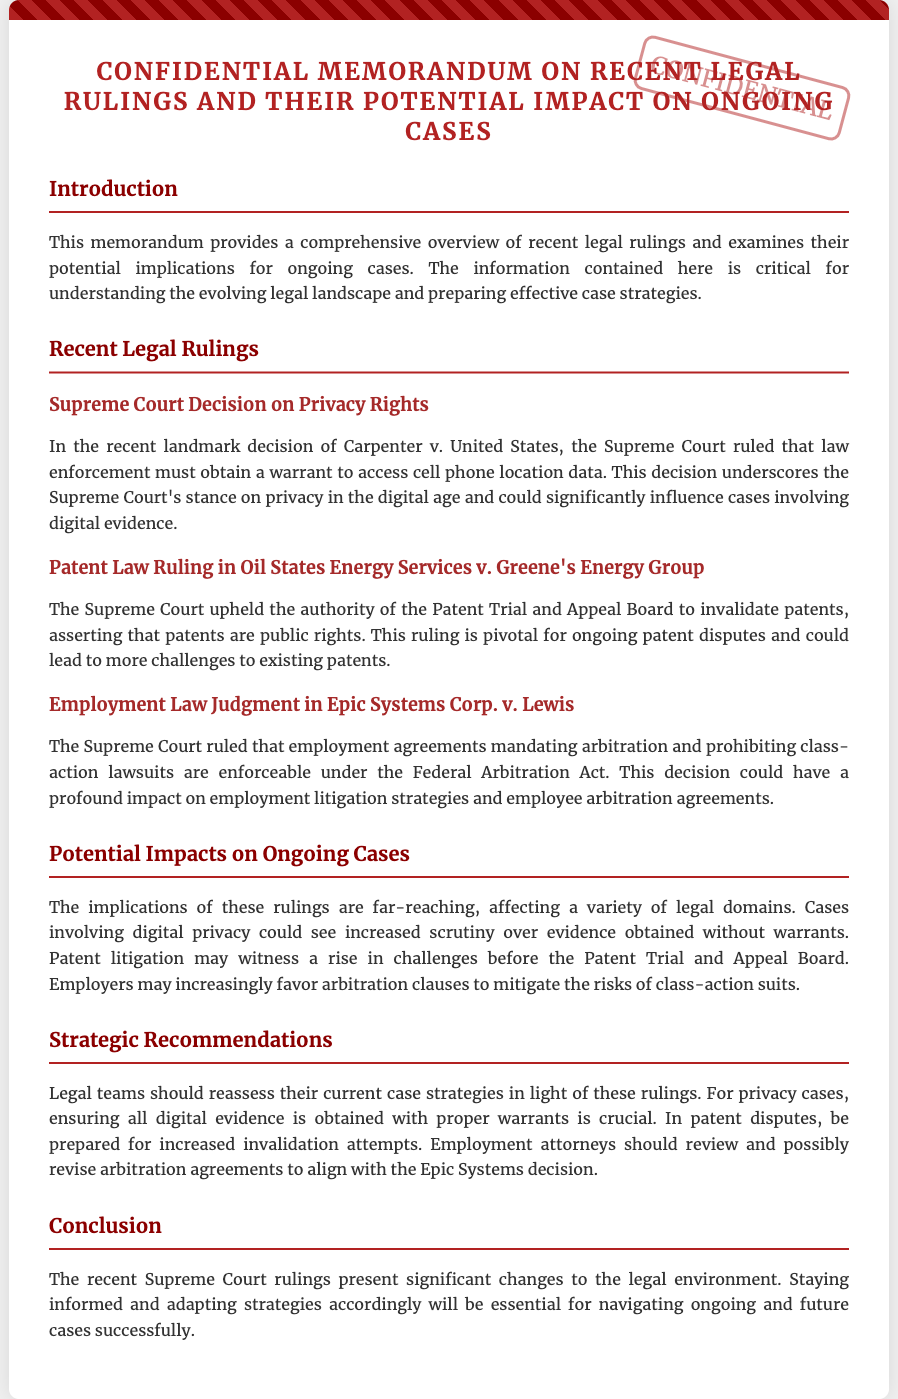What is the title of the memorandum? The title provides the main subject of the document, which is "Confidential Memorandum on Recent Legal Rulings and Their Potential Impact on Ongoing Cases".
Answer: Confidential Memorandum on Recent Legal Rulings and Their Potential Impact on Ongoing Cases What Supreme Court case addressed privacy rights? This refers to a specific legal case discussed in the document, which is "Carpenter v. United States".
Answer: Carpenter v. United States What ruling was made regarding patent law? This refers to the legal ruling mentioned that involves patents, specifically in "Oil States Energy Services v. Greene's Energy Group".
Answer: Oil States Energy Services v. Greene's Energy Group Which act does the Epic Systems Corp. v. Lewis case relate to? This question identifies the legal framework involved in the employment law ruling mentioned in the document.
Answer: Federal Arbitration Act What is one strategic recommendation for legal teams? This refers to advice given in the document that emphasizes the importance of a specific action legal teams should take.
Answer: Reassess current case strategies How many recent legal rulings are discussed? This question seeks to identify the count of major segments covered in the memorandum.
Answer: Three What is the implications of the Carpenter v. United States decision? This assesses the potential influence of a specific ruling on future cases, particularly those involving digital evidence.
Answer: Increased scrutiny over evidence obtained without warrants What color is the confidential stamp? This question focuses on the visual aspects of the document related to the confidentiality notice.
Answer: Red What area of law does Epic Systems Corp. v. Lewis impact? The question requires identification of the specific domain affected by the ruling mentioned.
Answer: Employment law 